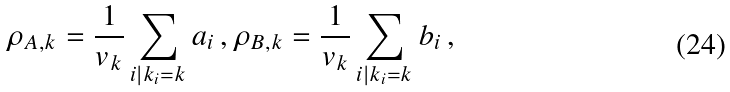Convert formula to latex. <formula><loc_0><loc_0><loc_500><loc_500>\rho _ { A , k } = \frac { 1 } { v _ { k } } \sum _ { i | k _ { i } = k } a _ { i } \, , \rho _ { B , k } = \frac { 1 } { v _ { k } } \sum _ { i | k _ { i } = k } b _ { i } \, ,</formula> 